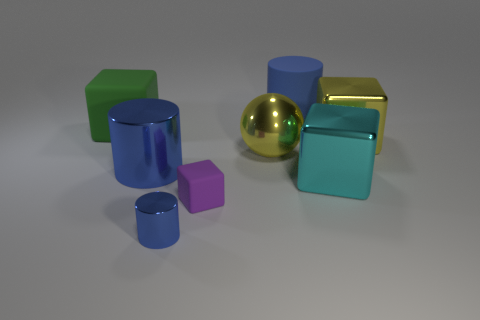Can you describe the lighting and shadow effects in the picture? The image features a softened overhead lighting that casts gentle shadows beneath each object. The smoothness of the shadows suggests a diffused light source. The reflections on the golden objects also indicate that the light is not overly harsh, creating a serene ambiance. 